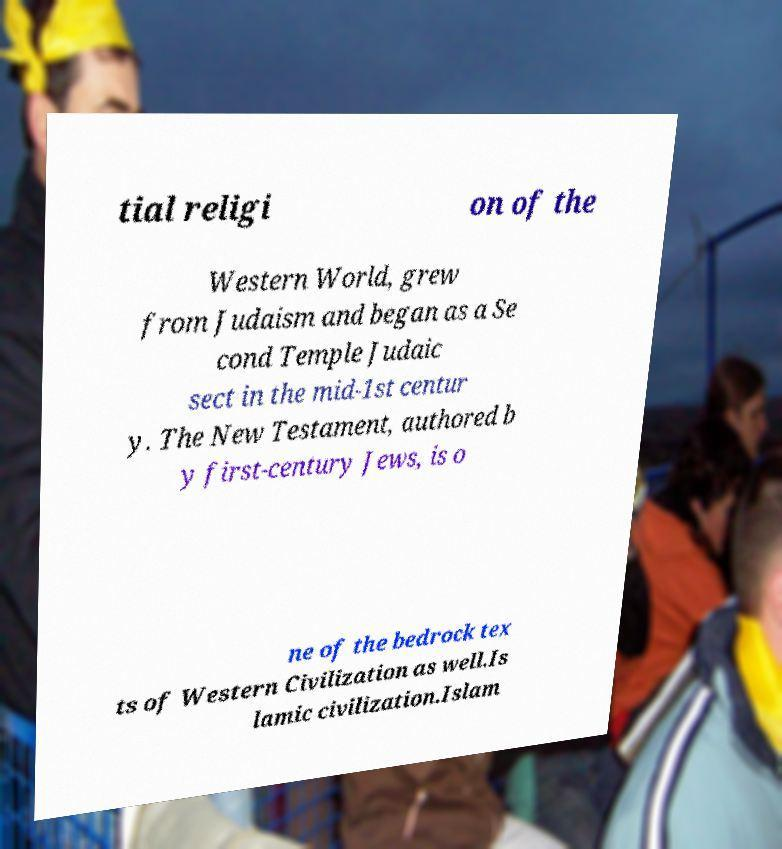I need the written content from this picture converted into text. Can you do that? tial religi on of the Western World, grew from Judaism and began as a Se cond Temple Judaic sect in the mid-1st centur y. The New Testament, authored b y first-century Jews, is o ne of the bedrock tex ts of Western Civilization as well.Is lamic civilization.Islam 